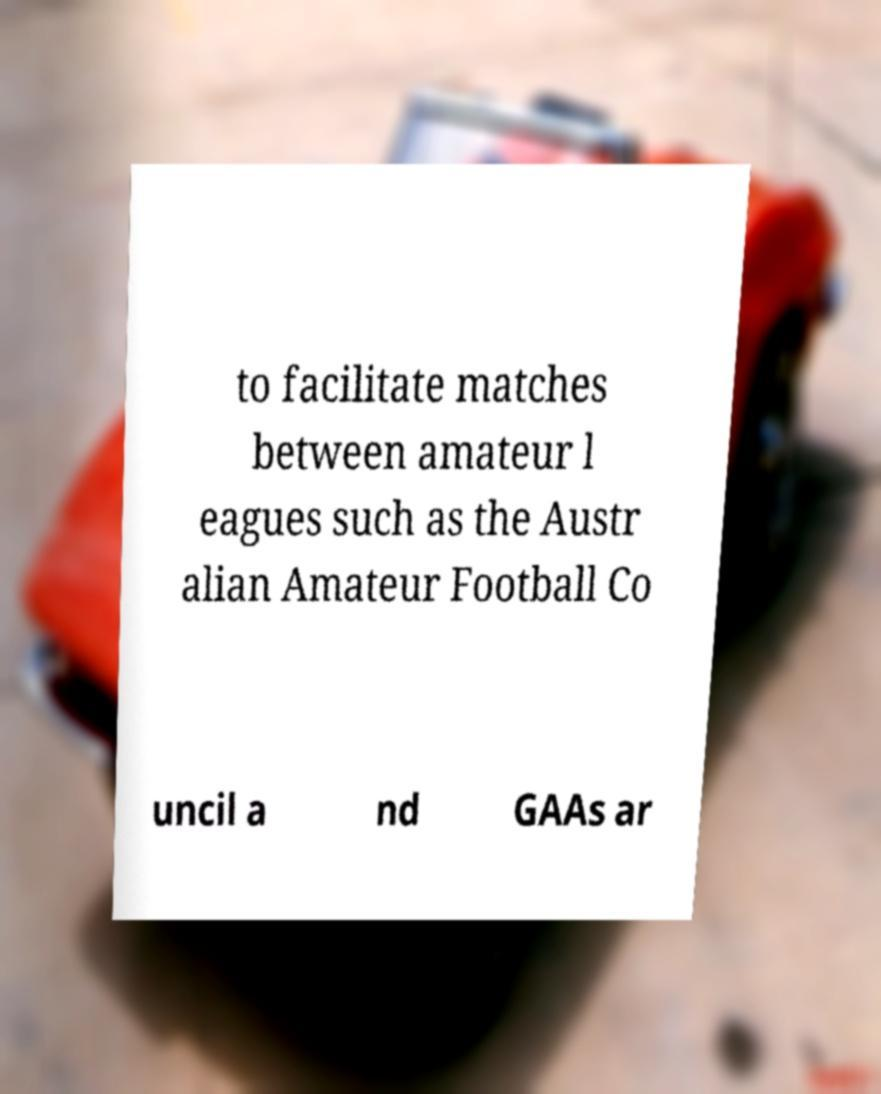There's text embedded in this image that I need extracted. Can you transcribe it verbatim? to facilitate matches between amateur l eagues such as the Austr alian Amateur Football Co uncil a nd GAAs ar 